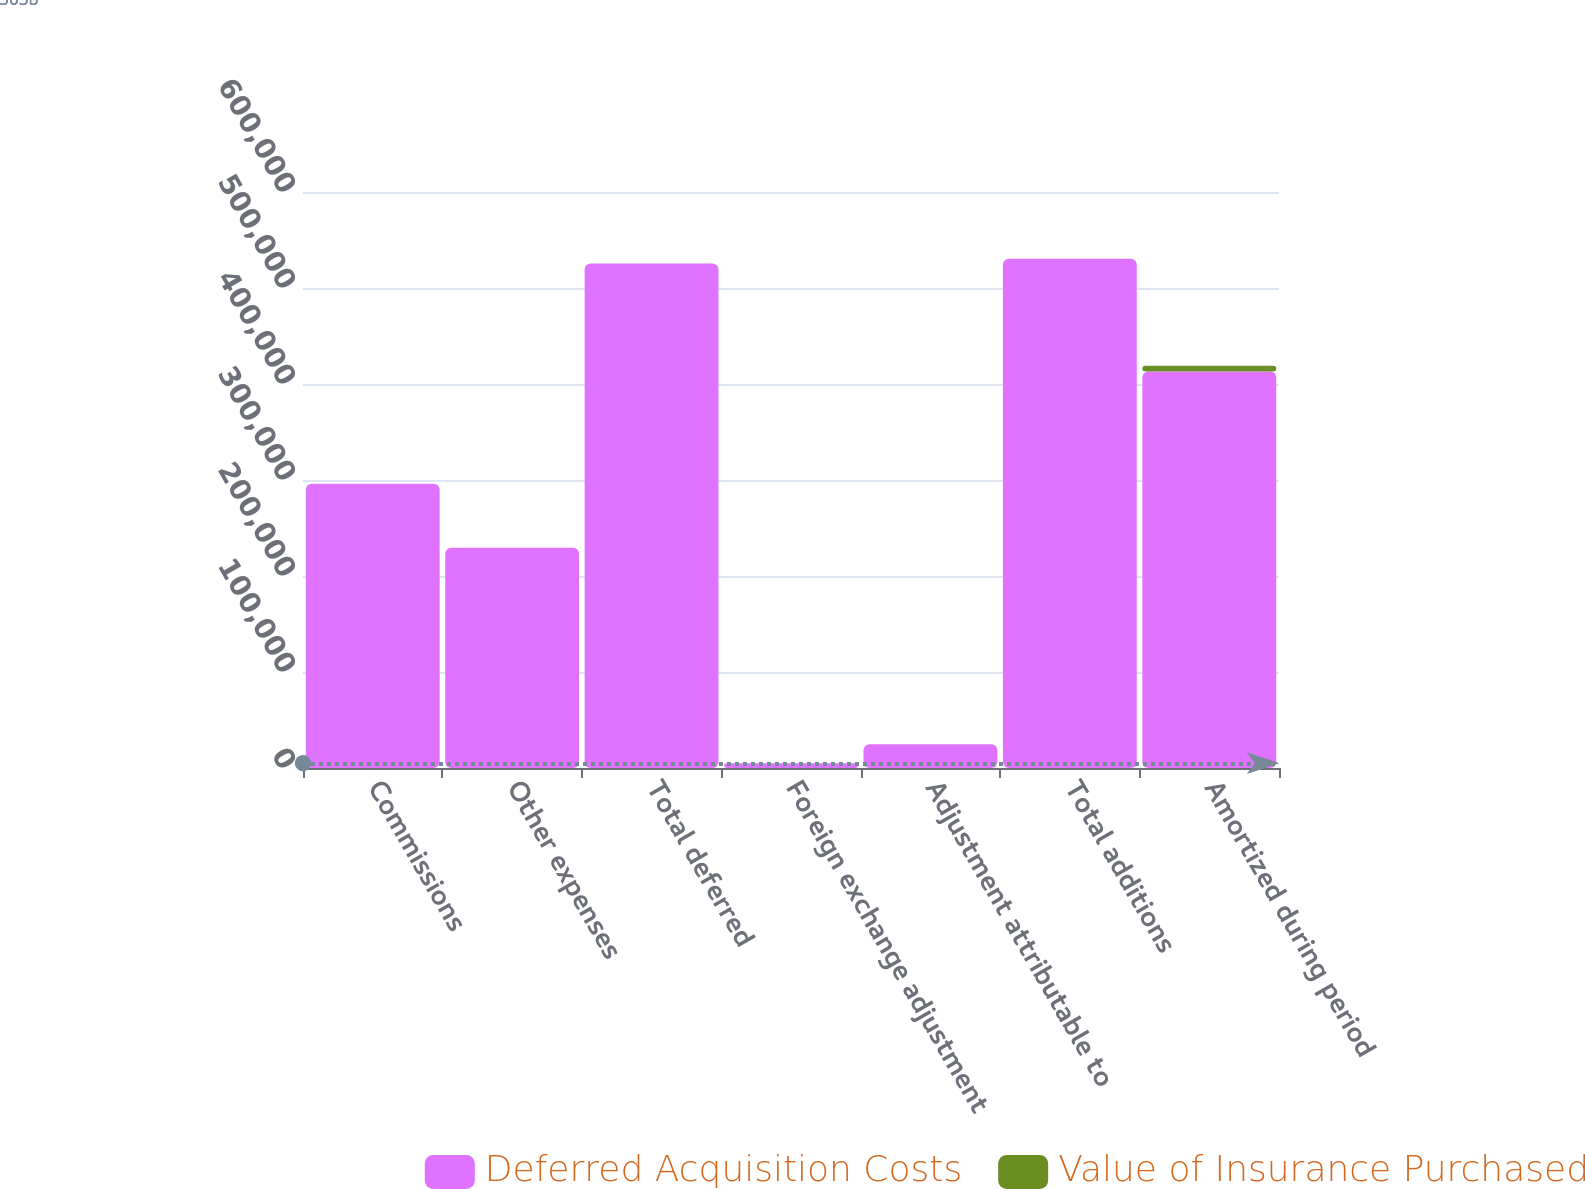Convert chart. <chart><loc_0><loc_0><loc_500><loc_500><stacked_bar_chart><ecel><fcel>Commissions<fcel>Other expenses<fcel>Total deferred<fcel>Foreign exchange adjustment<fcel>Adjustment attributable to<fcel>Total additions<fcel>Amortized during period<nl><fcel>Deferred Acquisition Costs<fcel>296043<fcel>229367<fcel>525410<fcel>5038<fcel>24745<fcel>530448<fcel>413114<nl><fcel>Value of Insurance Purchased<fcel>0<fcel>0<fcel>0<fcel>17<fcel>0<fcel>17<fcel>5776<nl></chart> 